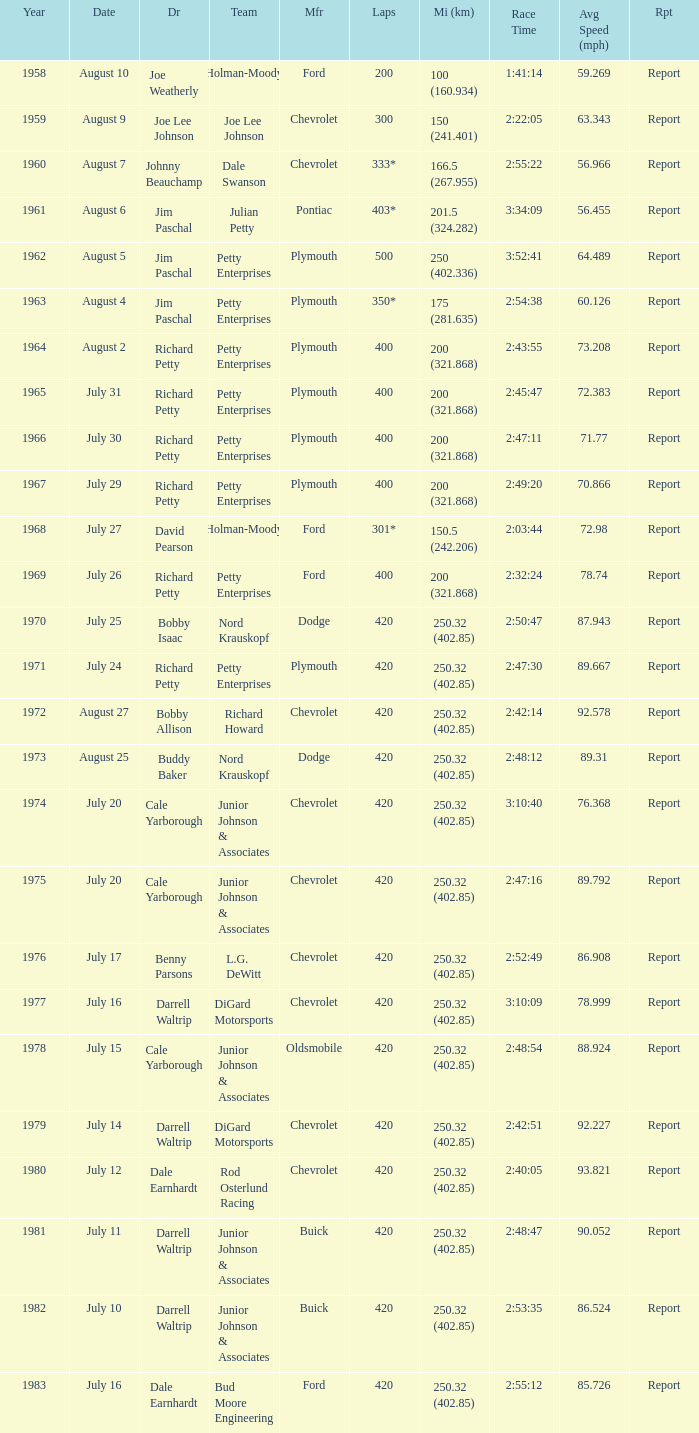What year had a race with 301* laps? 1968.0. 